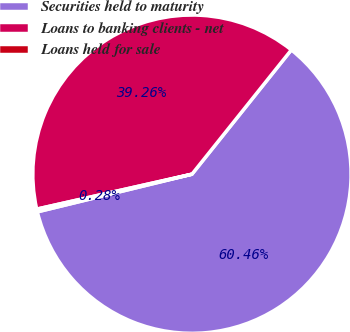<chart> <loc_0><loc_0><loc_500><loc_500><pie_chart><fcel>Securities held to maturity<fcel>Loans to banking clients - net<fcel>Loans held for sale<nl><fcel>60.46%<fcel>39.26%<fcel>0.28%<nl></chart> 